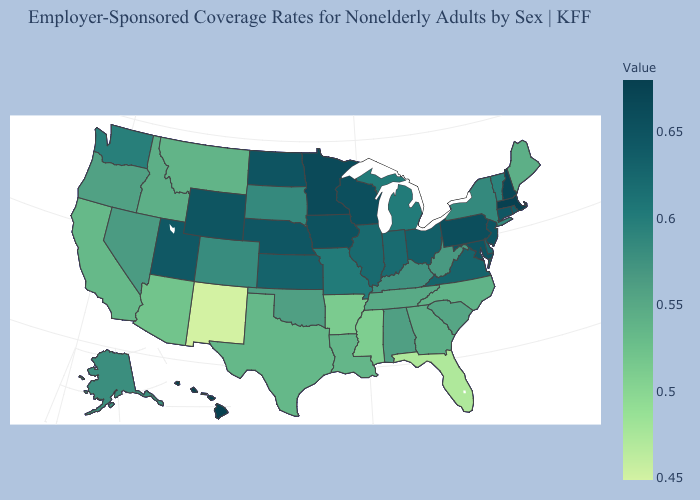Does Missouri have the highest value in the MidWest?
Give a very brief answer. No. Does Indiana have a higher value than Alabama?
Quick response, please. Yes. Among the states that border Alabama , does Tennessee have the highest value?
Give a very brief answer. Yes. Which states have the lowest value in the South?
Concise answer only. Florida. Does South Dakota have the lowest value in the MidWest?
Short answer required. Yes. Which states have the lowest value in the Northeast?
Write a very short answer. Maine. Does Michigan have a lower value than West Virginia?
Concise answer only. No. Among the states that border Tennessee , which have the highest value?
Short answer required. Virginia. Does Massachusetts have the highest value in the USA?
Write a very short answer. Yes. 